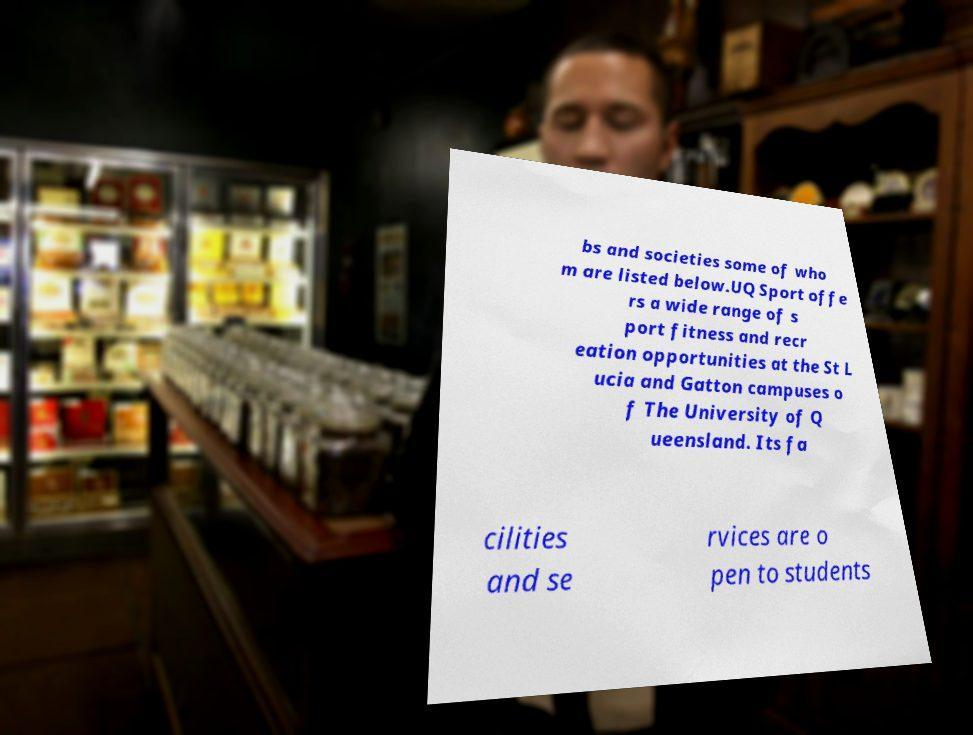What messages or text are displayed in this image? I need them in a readable, typed format. bs and societies some of who m are listed below.UQ Sport offe rs a wide range of s port fitness and recr eation opportunities at the St L ucia and Gatton campuses o f The University of Q ueensland. Its fa cilities and se rvices are o pen to students 